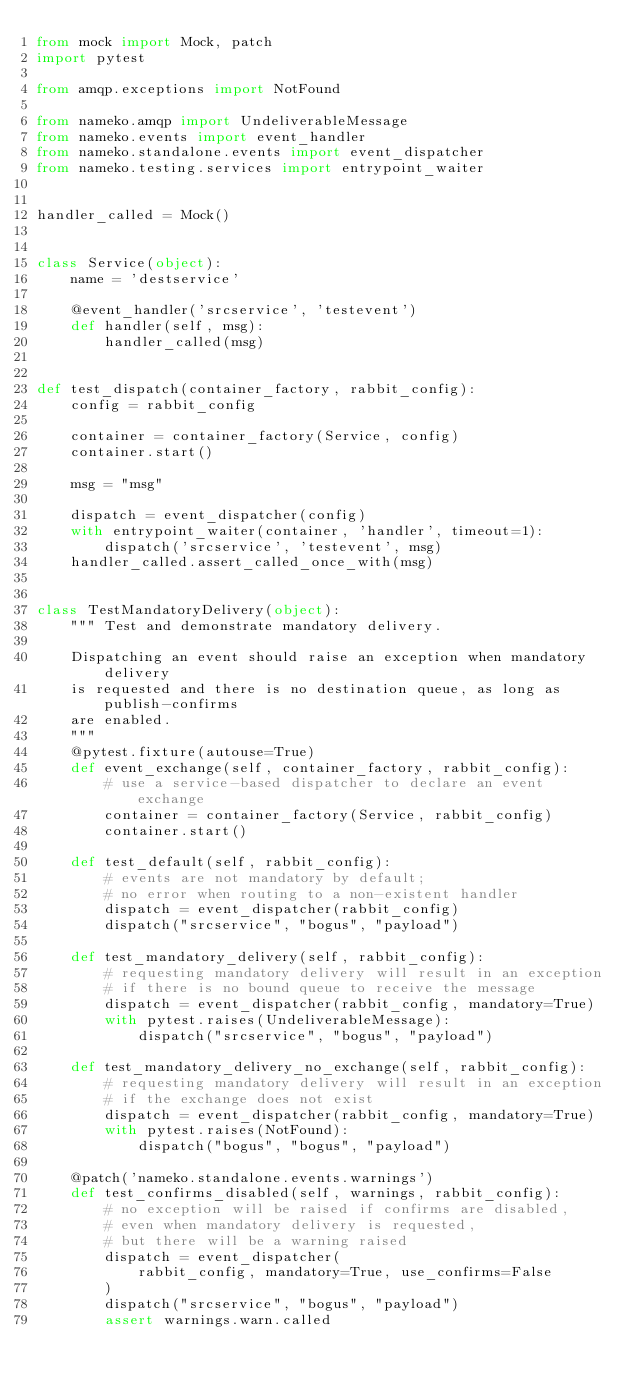<code> <loc_0><loc_0><loc_500><loc_500><_Python_>from mock import Mock, patch
import pytest

from amqp.exceptions import NotFound

from nameko.amqp import UndeliverableMessage
from nameko.events import event_handler
from nameko.standalone.events import event_dispatcher
from nameko.testing.services import entrypoint_waiter


handler_called = Mock()


class Service(object):
    name = 'destservice'

    @event_handler('srcservice', 'testevent')
    def handler(self, msg):
        handler_called(msg)


def test_dispatch(container_factory, rabbit_config):
    config = rabbit_config

    container = container_factory(Service, config)
    container.start()

    msg = "msg"

    dispatch = event_dispatcher(config)
    with entrypoint_waiter(container, 'handler', timeout=1):
        dispatch('srcservice', 'testevent', msg)
    handler_called.assert_called_once_with(msg)


class TestMandatoryDelivery(object):
    """ Test and demonstrate mandatory delivery.

    Dispatching an event should raise an exception when mandatory delivery
    is requested and there is no destination queue, as long as publish-confirms
    are enabled.
    """
    @pytest.fixture(autouse=True)
    def event_exchange(self, container_factory, rabbit_config):
        # use a service-based dispatcher to declare an event exchange
        container = container_factory(Service, rabbit_config)
        container.start()

    def test_default(self, rabbit_config):
        # events are not mandatory by default;
        # no error when routing to a non-existent handler
        dispatch = event_dispatcher(rabbit_config)
        dispatch("srcservice", "bogus", "payload")

    def test_mandatory_delivery(self, rabbit_config):
        # requesting mandatory delivery will result in an exception
        # if there is no bound queue to receive the message
        dispatch = event_dispatcher(rabbit_config, mandatory=True)
        with pytest.raises(UndeliverableMessage):
            dispatch("srcservice", "bogus", "payload")

    def test_mandatory_delivery_no_exchange(self, rabbit_config):
        # requesting mandatory delivery will result in an exception
        # if the exchange does not exist
        dispatch = event_dispatcher(rabbit_config, mandatory=True)
        with pytest.raises(NotFound):
            dispatch("bogus", "bogus", "payload")

    @patch('nameko.standalone.events.warnings')
    def test_confirms_disabled(self, warnings, rabbit_config):
        # no exception will be raised if confirms are disabled,
        # even when mandatory delivery is requested,
        # but there will be a warning raised
        dispatch = event_dispatcher(
            rabbit_config, mandatory=True, use_confirms=False
        )
        dispatch("srcservice", "bogus", "payload")
        assert warnings.warn.called
</code> 